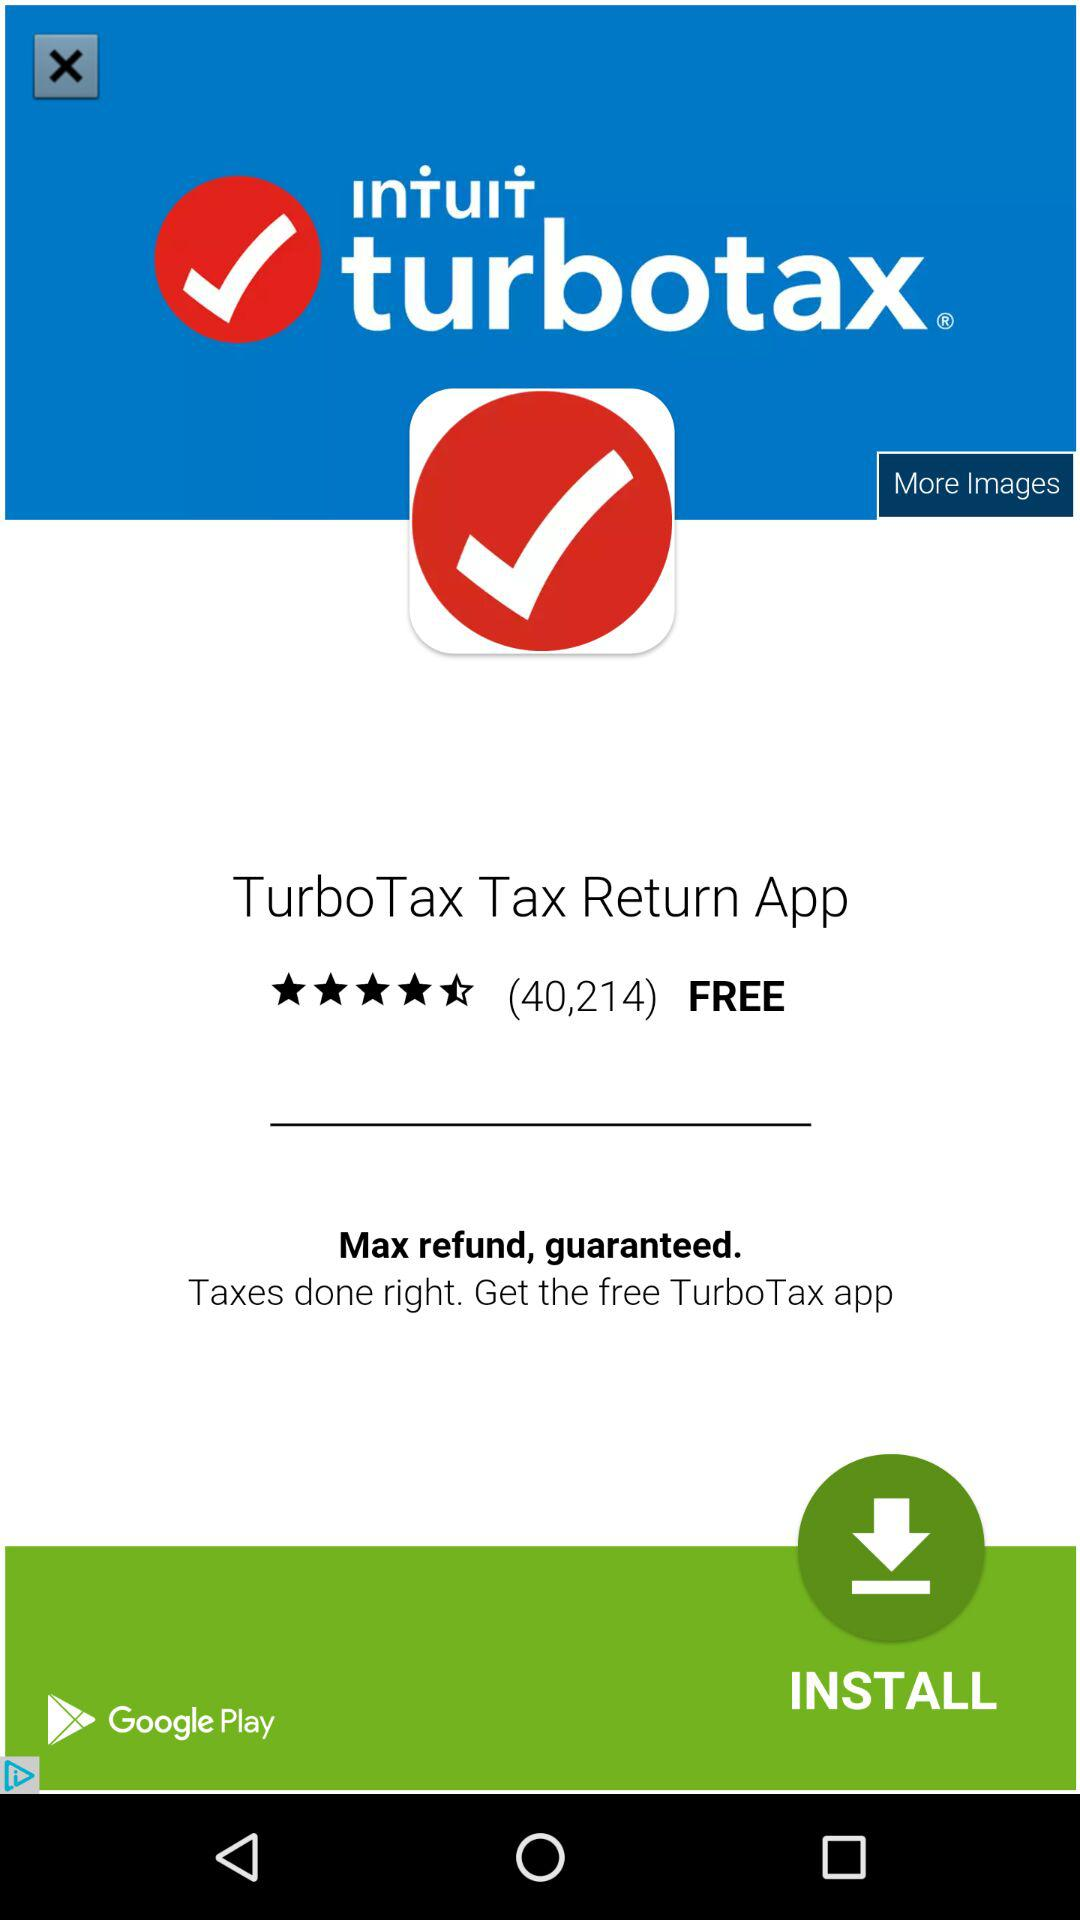What is the application's rating? The rating is 4.5 stars. 